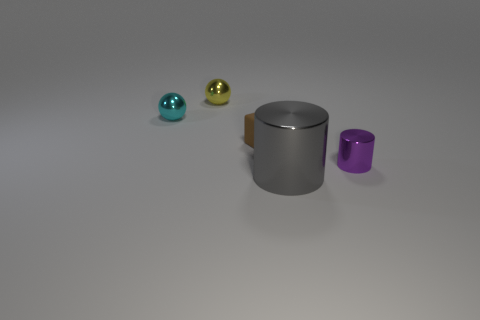Add 1 tiny metallic objects. How many objects exist? 6 Subtract all cubes. How many objects are left? 4 Subtract 0 gray blocks. How many objects are left? 5 Subtract all tiny shiny things. Subtract all tiny cyan metallic spheres. How many objects are left? 1 Add 1 small brown rubber things. How many small brown rubber things are left? 2 Add 2 tiny purple cylinders. How many tiny purple cylinders exist? 3 